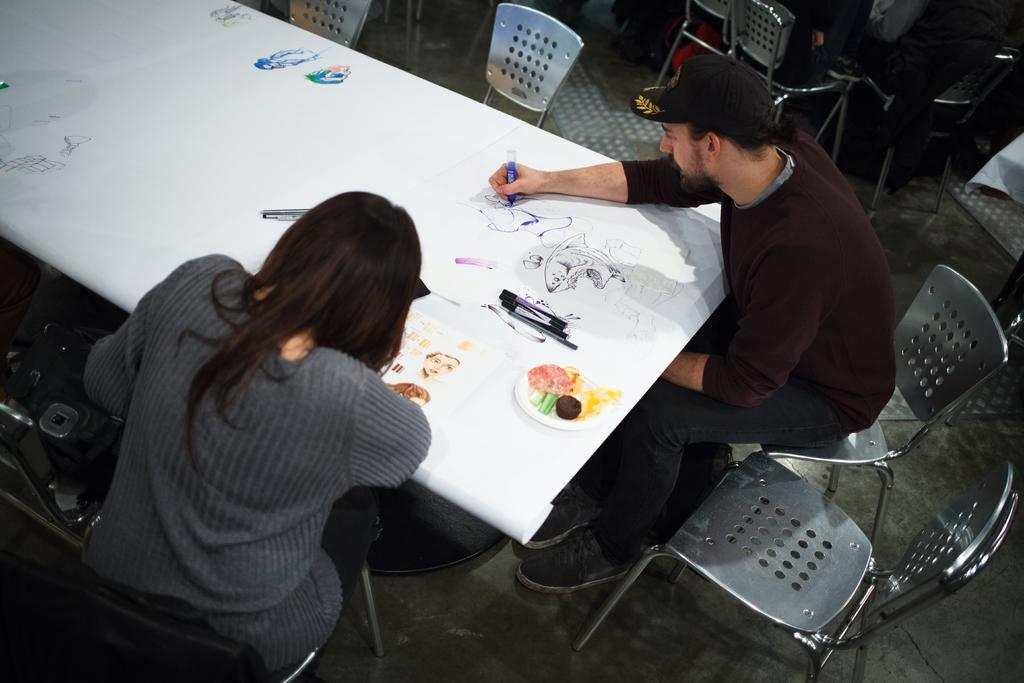How many people are in the image? There are two people in the image, a man and a woman. What are the man and woman doing in the image? The man is drawing something on the table, and the woman is observing his drawing. What are they sitting on in the image? They are both sitting on chairs. What is the man wearing on his head in the image? The man is wearing a cap. What type of prison can be seen in the background of the image? There is no prison visible in the image; it features a man and a woman sitting in front of a table. What condition is the sock in that the man is wearing in the image? The man is not wearing a sock in the image; he is wearing a cap. 